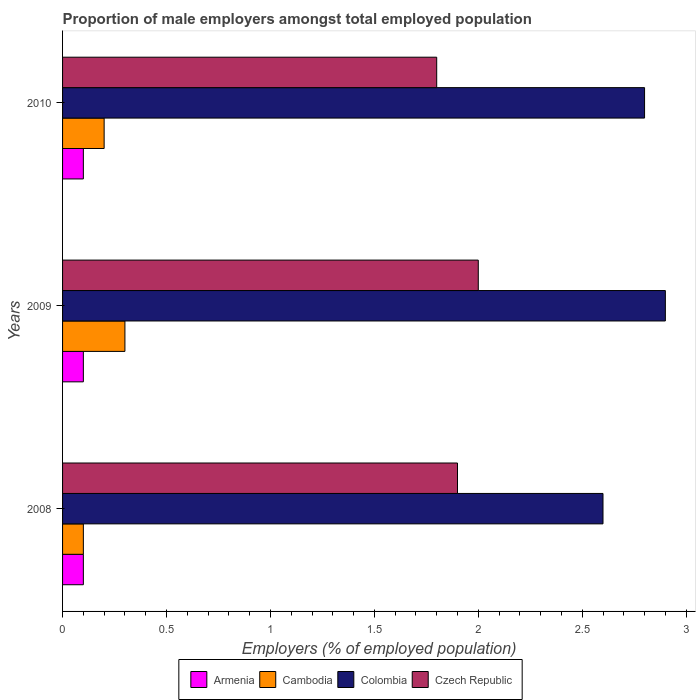How many different coloured bars are there?
Your answer should be compact. 4. How many groups of bars are there?
Offer a very short reply. 3. Are the number of bars on each tick of the Y-axis equal?
Give a very brief answer. Yes. How many bars are there on the 1st tick from the top?
Provide a short and direct response. 4. How many bars are there on the 2nd tick from the bottom?
Give a very brief answer. 4. What is the label of the 1st group of bars from the top?
Provide a succinct answer. 2010. What is the proportion of male employers in Armenia in 2009?
Ensure brevity in your answer.  0.1. Across all years, what is the maximum proportion of male employers in Colombia?
Your answer should be compact. 2.9. Across all years, what is the minimum proportion of male employers in Colombia?
Offer a terse response. 2.6. In which year was the proportion of male employers in Colombia maximum?
Provide a succinct answer. 2009. In which year was the proportion of male employers in Colombia minimum?
Offer a very short reply. 2008. What is the total proportion of male employers in Colombia in the graph?
Your answer should be compact. 8.3. What is the difference between the proportion of male employers in Cambodia in 2009 and that in 2010?
Make the answer very short. 0.1. What is the difference between the proportion of male employers in Armenia in 2010 and the proportion of male employers in Czech Republic in 2008?
Your response must be concise. -1.8. What is the average proportion of male employers in Czech Republic per year?
Your answer should be very brief. 1.9. In the year 2010, what is the difference between the proportion of male employers in Cambodia and proportion of male employers in Colombia?
Ensure brevity in your answer.  -2.6. What is the ratio of the proportion of male employers in Armenia in 2009 to that in 2010?
Make the answer very short. 1. Is the proportion of male employers in Cambodia in 2008 less than that in 2009?
Provide a succinct answer. Yes. What is the difference between the highest and the second highest proportion of male employers in Cambodia?
Your answer should be very brief. 0.1. What is the difference between the highest and the lowest proportion of male employers in Colombia?
Your response must be concise. 0.3. In how many years, is the proportion of male employers in Cambodia greater than the average proportion of male employers in Cambodia taken over all years?
Your answer should be compact. 1. Is the sum of the proportion of male employers in Armenia in 2009 and 2010 greater than the maximum proportion of male employers in Colombia across all years?
Offer a very short reply. No. What does the 3rd bar from the top in 2009 represents?
Offer a very short reply. Cambodia. What does the 3rd bar from the bottom in 2009 represents?
Provide a short and direct response. Colombia. How many bars are there?
Offer a terse response. 12. Are all the bars in the graph horizontal?
Provide a short and direct response. Yes. How many years are there in the graph?
Give a very brief answer. 3. Where does the legend appear in the graph?
Provide a short and direct response. Bottom center. How many legend labels are there?
Provide a succinct answer. 4. How are the legend labels stacked?
Offer a terse response. Horizontal. What is the title of the graph?
Offer a terse response. Proportion of male employers amongst total employed population. What is the label or title of the X-axis?
Keep it short and to the point. Employers (% of employed population). What is the Employers (% of employed population) of Armenia in 2008?
Your response must be concise. 0.1. What is the Employers (% of employed population) of Cambodia in 2008?
Your response must be concise. 0.1. What is the Employers (% of employed population) in Colombia in 2008?
Your answer should be very brief. 2.6. What is the Employers (% of employed population) in Czech Republic in 2008?
Your response must be concise. 1.9. What is the Employers (% of employed population) of Armenia in 2009?
Offer a very short reply. 0.1. What is the Employers (% of employed population) in Cambodia in 2009?
Ensure brevity in your answer.  0.3. What is the Employers (% of employed population) of Colombia in 2009?
Your answer should be compact. 2.9. What is the Employers (% of employed population) of Armenia in 2010?
Your answer should be compact. 0.1. What is the Employers (% of employed population) of Cambodia in 2010?
Give a very brief answer. 0.2. What is the Employers (% of employed population) of Colombia in 2010?
Your answer should be very brief. 2.8. What is the Employers (% of employed population) of Czech Republic in 2010?
Offer a terse response. 1.8. Across all years, what is the maximum Employers (% of employed population) of Armenia?
Offer a terse response. 0.1. Across all years, what is the maximum Employers (% of employed population) of Cambodia?
Provide a succinct answer. 0.3. Across all years, what is the maximum Employers (% of employed population) in Colombia?
Provide a succinct answer. 2.9. Across all years, what is the maximum Employers (% of employed population) in Czech Republic?
Your answer should be very brief. 2. Across all years, what is the minimum Employers (% of employed population) in Armenia?
Keep it short and to the point. 0.1. Across all years, what is the minimum Employers (% of employed population) of Cambodia?
Offer a terse response. 0.1. Across all years, what is the minimum Employers (% of employed population) in Colombia?
Provide a short and direct response. 2.6. Across all years, what is the minimum Employers (% of employed population) in Czech Republic?
Provide a short and direct response. 1.8. What is the total Employers (% of employed population) of Colombia in the graph?
Provide a short and direct response. 8.3. What is the total Employers (% of employed population) of Czech Republic in the graph?
Your answer should be compact. 5.7. What is the difference between the Employers (% of employed population) of Armenia in 2008 and that in 2009?
Keep it short and to the point. 0. What is the difference between the Employers (% of employed population) in Cambodia in 2008 and that in 2009?
Your answer should be compact. -0.2. What is the difference between the Employers (% of employed population) in Colombia in 2008 and that in 2009?
Your answer should be very brief. -0.3. What is the difference between the Employers (% of employed population) of Colombia in 2008 and that in 2010?
Make the answer very short. -0.2. What is the difference between the Employers (% of employed population) of Czech Republic in 2008 and that in 2010?
Your answer should be very brief. 0.1. What is the difference between the Employers (% of employed population) in Armenia in 2009 and that in 2010?
Offer a very short reply. 0. What is the difference between the Employers (% of employed population) of Colombia in 2009 and that in 2010?
Offer a terse response. 0.1. What is the difference between the Employers (% of employed population) of Czech Republic in 2009 and that in 2010?
Make the answer very short. 0.2. What is the difference between the Employers (% of employed population) of Armenia in 2008 and the Employers (% of employed population) of Colombia in 2009?
Your response must be concise. -2.8. What is the difference between the Employers (% of employed population) in Cambodia in 2008 and the Employers (% of employed population) in Czech Republic in 2009?
Ensure brevity in your answer.  -1.9. What is the difference between the Employers (% of employed population) in Colombia in 2008 and the Employers (% of employed population) in Czech Republic in 2009?
Provide a short and direct response. 0.6. What is the difference between the Employers (% of employed population) in Armenia in 2009 and the Employers (% of employed population) in Colombia in 2010?
Your answer should be very brief. -2.7. What is the difference between the Employers (% of employed population) of Cambodia in 2009 and the Employers (% of employed population) of Czech Republic in 2010?
Give a very brief answer. -1.5. What is the difference between the Employers (% of employed population) of Colombia in 2009 and the Employers (% of employed population) of Czech Republic in 2010?
Offer a very short reply. 1.1. What is the average Employers (% of employed population) in Armenia per year?
Offer a terse response. 0.1. What is the average Employers (% of employed population) in Colombia per year?
Your answer should be compact. 2.77. In the year 2008, what is the difference between the Employers (% of employed population) in Cambodia and Employers (% of employed population) in Czech Republic?
Your response must be concise. -1.8. In the year 2008, what is the difference between the Employers (% of employed population) of Colombia and Employers (% of employed population) of Czech Republic?
Provide a succinct answer. 0.7. In the year 2009, what is the difference between the Employers (% of employed population) of Armenia and Employers (% of employed population) of Cambodia?
Your answer should be compact. -0.2. In the year 2009, what is the difference between the Employers (% of employed population) of Armenia and Employers (% of employed population) of Colombia?
Offer a very short reply. -2.8. In the year 2009, what is the difference between the Employers (% of employed population) in Armenia and Employers (% of employed population) in Czech Republic?
Give a very brief answer. -1.9. In the year 2009, what is the difference between the Employers (% of employed population) in Cambodia and Employers (% of employed population) in Czech Republic?
Give a very brief answer. -1.7. In the year 2010, what is the difference between the Employers (% of employed population) in Armenia and Employers (% of employed population) in Cambodia?
Keep it short and to the point. -0.1. In the year 2010, what is the difference between the Employers (% of employed population) in Armenia and Employers (% of employed population) in Colombia?
Your answer should be compact. -2.7. In the year 2010, what is the difference between the Employers (% of employed population) in Cambodia and Employers (% of employed population) in Colombia?
Ensure brevity in your answer.  -2.6. In the year 2010, what is the difference between the Employers (% of employed population) of Cambodia and Employers (% of employed population) of Czech Republic?
Your answer should be very brief. -1.6. In the year 2010, what is the difference between the Employers (% of employed population) in Colombia and Employers (% of employed population) in Czech Republic?
Offer a terse response. 1. What is the ratio of the Employers (% of employed population) in Armenia in 2008 to that in 2009?
Keep it short and to the point. 1. What is the ratio of the Employers (% of employed population) in Cambodia in 2008 to that in 2009?
Provide a short and direct response. 0.33. What is the ratio of the Employers (% of employed population) of Colombia in 2008 to that in 2009?
Give a very brief answer. 0.9. What is the ratio of the Employers (% of employed population) in Cambodia in 2008 to that in 2010?
Your answer should be compact. 0.5. What is the ratio of the Employers (% of employed population) of Czech Republic in 2008 to that in 2010?
Your response must be concise. 1.06. What is the ratio of the Employers (% of employed population) of Cambodia in 2009 to that in 2010?
Offer a very short reply. 1.5. What is the ratio of the Employers (% of employed population) in Colombia in 2009 to that in 2010?
Ensure brevity in your answer.  1.04. What is the ratio of the Employers (% of employed population) in Czech Republic in 2009 to that in 2010?
Make the answer very short. 1.11. What is the difference between the highest and the second highest Employers (% of employed population) in Armenia?
Offer a terse response. 0. What is the difference between the highest and the second highest Employers (% of employed population) of Czech Republic?
Offer a terse response. 0.1. What is the difference between the highest and the lowest Employers (% of employed population) of Cambodia?
Make the answer very short. 0.2. 